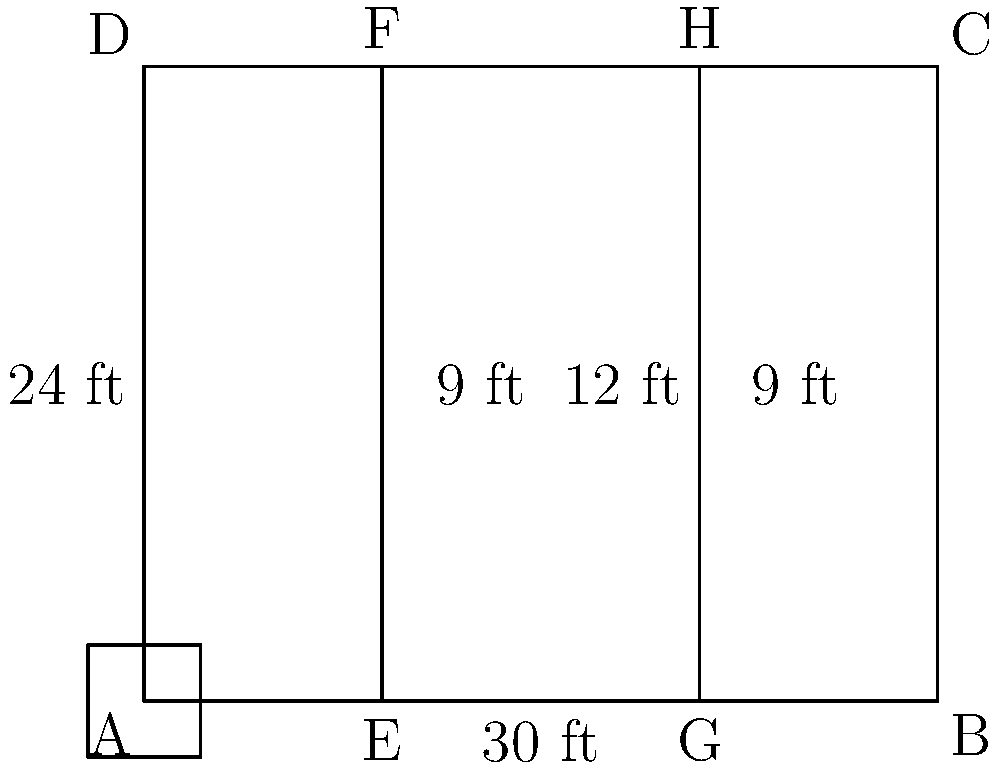Given the floor plan of your new office space as shown in the diagram, you want to maximize the usable area for workstations. If each workstation requires a minimum of 50 square feet, what is the maximum number of workstations that can be accommodated in the two larger sections (EFHG and BCHG) of the office, assuming 20% of the total area in these sections is reserved for walkways and common areas? Let's approach this step-by-step:

1. Calculate the total area of the office:
   Area = length × width = 30 ft × 24 ft = 720 sq ft

2. Calculate the areas of the two larger sections:
   Area of EFHG = 12 ft × 24 ft = 288 sq ft
   Area of BCHG = 9 ft × 24 ft = 216 sq ft

3. Calculate the total area of the two larger sections:
   Total area = 288 sq ft + 216 sq ft = 504 sq ft

4. Calculate the usable area after reserving 20% for walkways and common areas:
   Usable area = 80% of 504 sq ft = 0.8 × 504 sq ft = 403.2 sq ft

5. Calculate the number of workstations that can fit in the usable area:
   Number of workstations = Usable area ÷ Area per workstation
   Number of workstations = 403.2 sq ft ÷ 50 sq ft = 8.064

6. Since we can't have a fractional workstation, we round down to the nearest whole number.

Therefore, the maximum number of workstations that can be accommodated is 8.
Answer: 8 workstations 